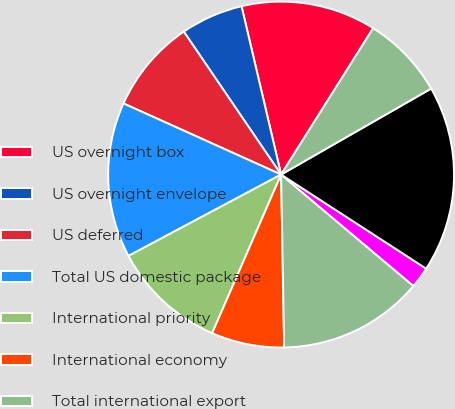<chart> <loc_0><loc_0><loc_500><loc_500><pie_chart><fcel>US overnight box<fcel>US overnight envelope<fcel>US deferred<fcel>Total US domestic package<fcel>International priority<fcel>International economy<fcel>Total international export<fcel>International domestic (1)<fcel>Total package revenue<fcel>US<nl><fcel>12.61%<fcel>5.84%<fcel>8.74%<fcel>14.54%<fcel>10.68%<fcel>6.81%<fcel>13.58%<fcel>1.98%<fcel>17.44%<fcel>7.78%<nl></chart> 